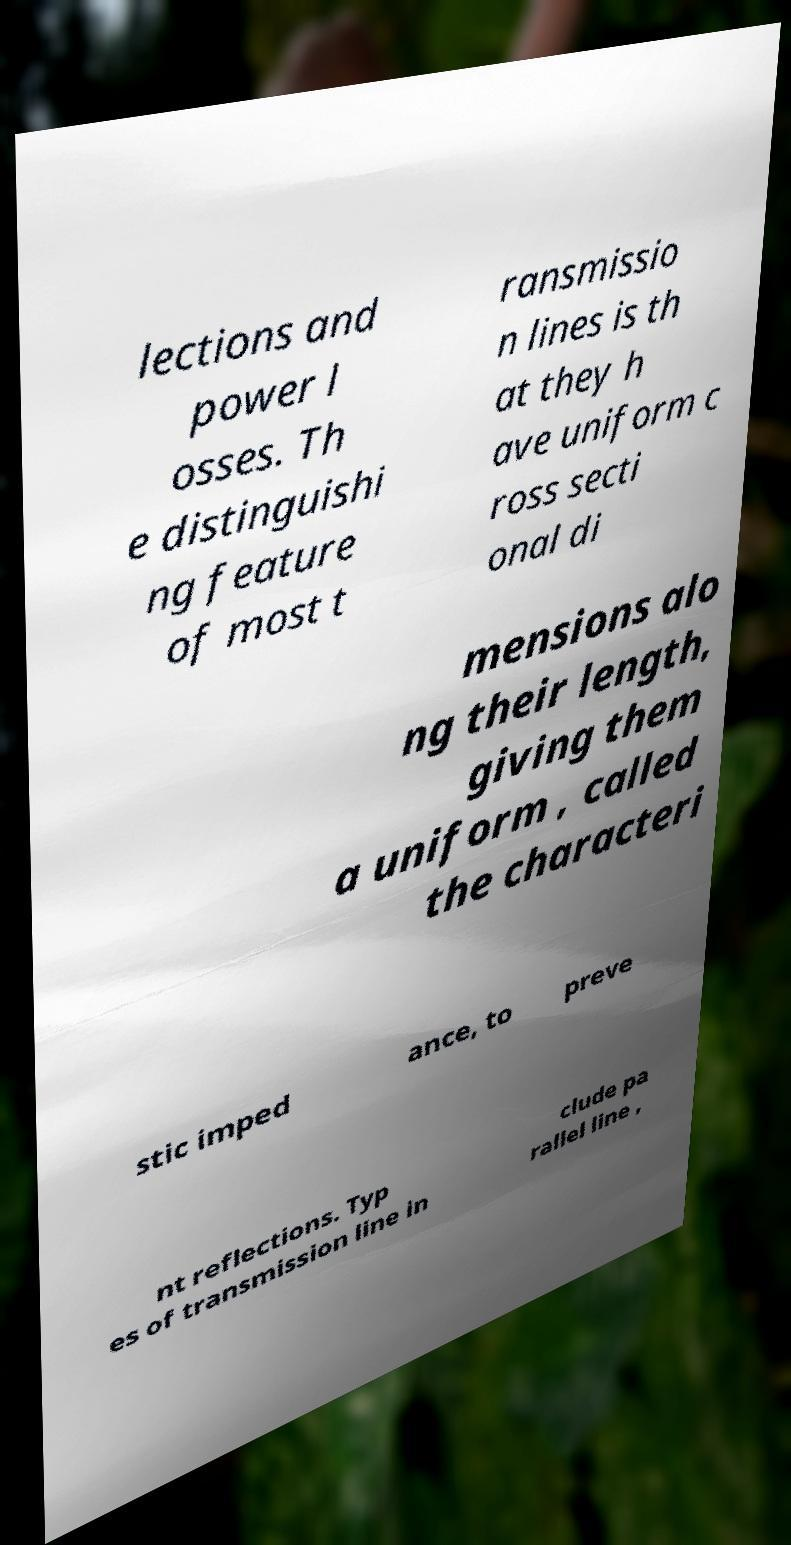Can you read and provide the text displayed in the image?This photo seems to have some interesting text. Can you extract and type it out for me? lections and power l osses. Th e distinguishi ng feature of most t ransmissio n lines is th at they h ave uniform c ross secti onal di mensions alo ng their length, giving them a uniform , called the characteri stic imped ance, to preve nt reflections. Typ es of transmission line in clude pa rallel line , 